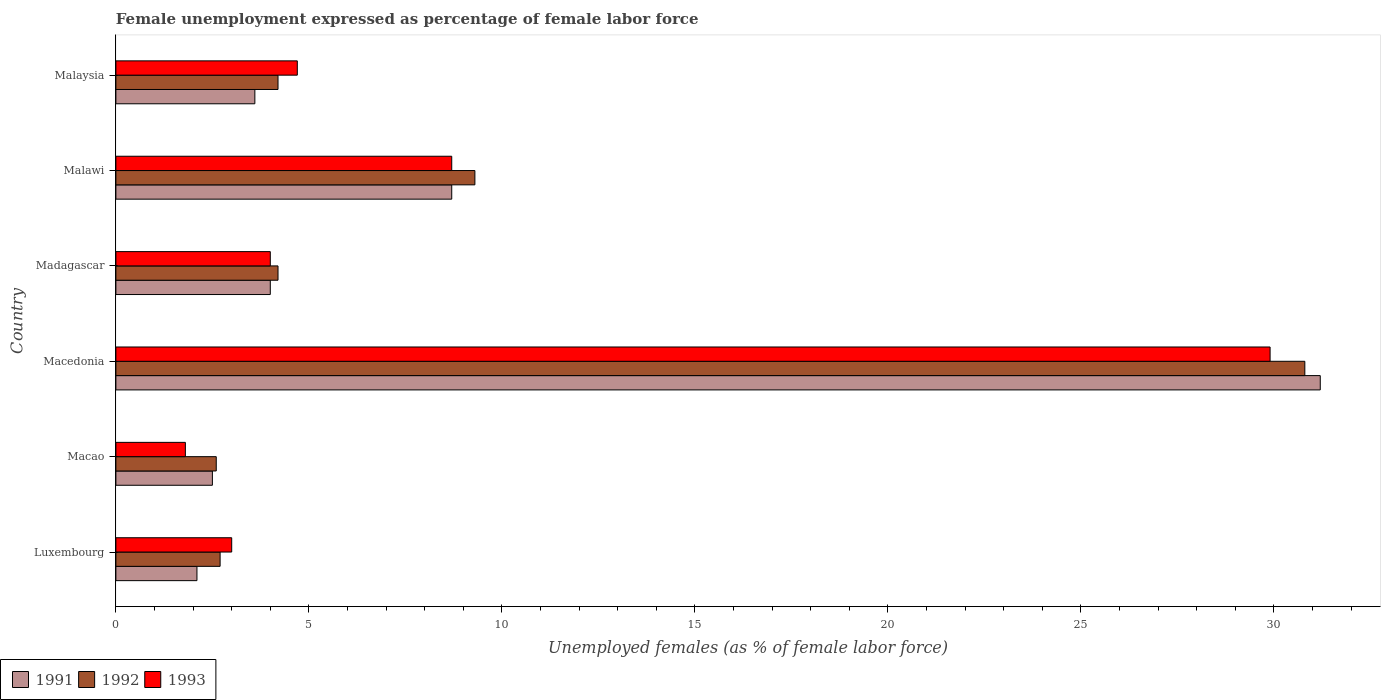How many different coloured bars are there?
Make the answer very short. 3. Are the number of bars on each tick of the Y-axis equal?
Give a very brief answer. Yes. How many bars are there on the 4th tick from the top?
Provide a succinct answer. 3. What is the label of the 4th group of bars from the top?
Ensure brevity in your answer.  Macedonia. In how many cases, is the number of bars for a given country not equal to the number of legend labels?
Ensure brevity in your answer.  0. What is the unemployment in females in in 1991 in Malawi?
Offer a very short reply. 8.7. Across all countries, what is the maximum unemployment in females in in 1992?
Make the answer very short. 30.8. Across all countries, what is the minimum unemployment in females in in 1993?
Your answer should be very brief. 1.8. In which country was the unemployment in females in in 1993 maximum?
Provide a short and direct response. Macedonia. In which country was the unemployment in females in in 1991 minimum?
Offer a terse response. Luxembourg. What is the total unemployment in females in in 1992 in the graph?
Keep it short and to the point. 53.8. What is the difference between the unemployment in females in in 1991 in Luxembourg and that in Malawi?
Your answer should be very brief. -6.6. What is the difference between the unemployment in females in in 1993 in Malaysia and the unemployment in females in in 1991 in Macedonia?
Ensure brevity in your answer.  -26.5. What is the average unemployment in females in in 1992 per country?
Make the answer very short. 8.97. What is the difference between the unemployment in females in in 1992 and unemployment in females in in 1993 in Malaysia?
Ensure brevity in your answer.  -0.5. In how many countries, is the unemployment in females in in 1992 greater than 7 %?
Make the answer very short. 2. What is the ratio of the unemployment in females in in 1993 in Luxembourg to that in Malaysia?
Your answer should be very brief. 0.64. What is the difference between the highest and the second highest unemployment in females in in 1991?
Offer a very short reply. 22.5. What is the difference between the highest and the lowest unemployment in females in in 1991?
Offer a terse response. 29.1. In how many countries, is the unemployment in females in in 1993 greater than the average unemployment in females in in 1993 taken over all countries?
Keep it short and to the point. 2. Is the sum of the unemployment in females in in 1993 in Luxembourg and Macao greater than the maximum unemployment in females in in 1991 across all countries?
Keep it short and to the point. No. How many bars are there?
Make the answer very short. 18. What is the difference between two consecutive major ticks on the X-axis?
Give a very brief answer. 5. Does the graph contain any zero values?
Give a very brief answer. No. Where does the legend appear in the graph?
Your answer should be very brief. Bottom left. How many legend labels are there?
Ensure brevity in your answer.  3. How are the legend labels stacked?
Ensure brevity in your answer.  Horizontal. What is the title of the graph?
Keep it short and to the point. Female unemployment expressed as percentage of female labor force. What is the label or title of the X-axis?
Your response must be concise. Unemployed females (as % of female labor force). What is the Unemployed females (as % of female labor force) of 1991 in Luxembourg?
Your answer should be compact. 2.1. What is the Unemployed females (as % of female labor force) of 1992 in Luxembourg?
Your response must be concise. 2.7. What is the Unemployed females (as % of female labor force) of 1991 in Macao?
Ensure brevity in your answer.  2.5. What is the Unemployed females (as % of female labor force) in 1992 in Macao?
Provide a succinct answer. 2.6. What is the Unemployed females (as % of female labor force) in 1993 in Macao?
Ensure brevity in your answer.  1.8. What is the Unemployed females (as % of female labor force) in 1991 in Macedonia?
Give a very brief answer. 31.2. What is the Unemployed females (as % of female labor force) of 1992 in Macedonia?
Your answer should be very brief. 30.8. What is the Unemployed females (as % of female labor force) of 1993 in Macedonia?
Your response must be concise. 29.9. What is the Unemployed females (as % of female labor force) of 1992 in Madagascar?
Ensure brevity in your answer.  4.2. What is the Unemployed females (as % of female labor force) of 1991 in Malawi?
Keep it short and to the point. 8.7. What is the Unemployed females (as % of female labor force) of 1992 in Malawi?
Offer a terse response. 9.3. What is the Unemployed females (as % of female labor force) in 1993 in Malawi?
Ensure brevity in your answer.  8.7. What is the Unemployed females (as % of female labor force) in 1991 in Malaysia?
Offer a very short reply. 3.6. What is the Unemployed females (as % of female labor force) of 1992 in Malaysia?
Keep it short and to the point. 4.2. What is the Unemployed females (as % of female labor force) of 1993 in Malaysia?
Your answer should be very brief. 4.7. Across all countries, what is the maximum Unemployed females (as % of female labor force) of 1991?
Provide a succinct answer. 31.2. Across all countries, what is the maximum Unemployed females (as % of female labor force) of 1992?
Your response must be concise. 30.8. Across all countries, what is the maximum Unemployed females (as % of female labor force) of 1993?
Keep it short and to the point. 29.9. Across all countries, what is the minimum Unemployed females (as % of female labor force) in 1991?
Your answer should be compact. 2.1. Across all countries, what is the minimum Unemployed females (as % of female labor force) of 1992?
Your answer should be very brief. 2.6. Across all countries, what is the minimum Unemployed females (as % of female labor force) of 1993?
Keep it short and to the point. 1.8. What is the total Unemployed females (as % of female labor force) in 1991 in the graph?
Make the answer very short. 52.1. What is the total Unemployed females (as % of female labor force) in 1992 in the graph?
Your answer should be very brief. 53.8. What is the total Unemployed females (as % of female labor force) of 1993 in the graph?
Make the answer very short. 52.1. What is the difference between the Unemployed females (as % of female labor force) in 1991 in Luxembourg and that in Macedonia?
Ensure brevity in your answer.  -29.1. What is the difference between the Unemployed females (as % of female labor force) in 1992 in Luxembourg and that in Macedonia?
Give a very brief answer. -28.1. What is the difference between the Unemployed females (as % of female labor force) in 1993 in Luxembourg and that in Macedonia?
Your response must be concise. -26.9. What is the difference between the Unemployed females (as % of female labor force) in 1991 in Luxembourg and that in Madagascar?
Ensure brevity in your answer.  -1.9. What is the difference between the Unemployed females (as % of female labor force) in 1992 in Luxembourg and that in Madagascar?
Offer a terse response. -1.5. What is the difference between the Unemployed females (as % of female labor force) in 1993 in Luxembourg and that in Madagascar?
Ensure brevity in your answer.  -1. What is the difference between the Unemployed females (as % of female labor force) of 1991 in Luxembourg and that in Malawi?
Your response must be concise. -6.6. What is the difference between the Unemployed females (as % of female labor force) in 1992 in Luxembourg and that in Malawi?
Your response must be concise. -6.6. What is the difference between the Unemployed females (as % of female labor force) in 1991 in Luxembourg and that in Malaysia?
Your response must be concise. -1.5. What is the difference between the Unemployed females (as % of female labor force) of 1992 in Luxembourg and that in Malaysia?
Provide a short and direct response. -1.5. What is the difference between the Unemployed females (as % of female labor force) of 1991 in Macao and that in Macedonia?
Give a very brief answer. -28.7. What is the difference between the Unemployed females (as % of female labor force) in 1992 in Macao and that in Macedonia?
Your response must be concise. -28.2. What is the difference between the Unemployed females (as % of female labor force) of 1993 in Macao and that in Macedonia?
Your response must be concise. -28.1. What is the difference between the Unemployed females (as % of female labor force) in 1991 in Macao and that in Madagascar?
Your response must be concise. -1.5. What is the difference between the Unemployed females (as % of female labor force) of 1993 in Macao and that in Madagascar?
Your answer should be compact. -2.2. What is the difference between the Unemployed females (as % of female labor force) in 1992 in Macao and that in Malawi?
Provide a succinct answer. -6.7. What is the difference between the Unemployed females (as % of female labor force) of 1993 in Macao and that in Malawi?
Your response must be concise. -6.9. What is the difference between the Unemployed females (as % of female labor force) of 1991 in Macao and that in Malaysia?
Your response must be concise. -1.1. What is the difference between the Unemployed females (as % of female labor force) in 1992 in Macao and that in Malaysia?
Offer a very short reply. -1.6. What is the difference between the Unemployed females (as % of female labor force) of 1993 in Macao and that in Malaysia?
Offer a terse response. -2.9. What is the difference between the Unemployed females (as % of female labor force) of 1991 in Macedonia and that in Madagascar?
Offer a terse response. 27.2. What is the difference between the Unemployed females (as % of female labor force) in 1992 in Macedonia and that in Madagascar?
Offer a very short reply. 26.6. What is the difference between the Unemployed females (as % of female labor force) of 1993 in Macedonia and that in Madagascar?
Keep it short and to the point. 25.9. What is the difference between the Unemployed females (as % of female labor force) of 1991 in Macedonia and that in Malawi?
Provide a succinct answer. 22.5. What is the difference between the Unemployed females (as % of female labor force) in 1992 in Macedonia and that in Malawi?
Give a very brief answer. 21.5. What is the difference between the Unemployed females (as % of female labor force) of 1993 in Macedonia and that in Malawi?
Offer a very short reply. 21.2. What is the difference between the Unemployed females (as % of female labor force) of 1991 in Macedonia and that in Malaysia?
Offer a very short reply. 27.6. What is the difference between the Unemployed females (as % of female labor force) in 1992 in Macedonia and that in Malaysia?
Your answer should be very brief. 26.6. What is the difference between the Unemployed females (as % of female labor force) of 1993 in Macedonia and that in Malaysia?
Provide a short and direct response. 25.2. What is the difference between the Unemployed females (as % of female labor force) of 1991 in Madagascar and that in Malawi?
Provide a succinct answer. -4.7. What is the difference between the Unemployed females (as % of female labor force) of 1993 in Madagascar and that in Malawi?
Offer a terse response. -4.7. What is the difference between the Unemployed females (as % of female labor force) in 1993 in Madagascar and that in Malaysia?
Your response must be concise. -0.7. What is the difference between the Unemployed females (as % of female labor force) of 1991 in Malawi and that in Malaysia?
Provide a succinct answer. 5.1. What is the difference between the Unemployed females (as % of female labor force) of 1992 in Malawi and that in Malaysia?
Give a very brief answer. 5.1. What is the difference between the Unemployed females (as % of female labor force) of 1993 in Malawi and that in Malaysia?
Ensure brevity in your answer.  4. What is the difference between the Unemployed females (as % of female labor force) of 1991 in Luxembourg and the Unemployed females (as % of female labor force) of 1992 in Macao?
Your response must be concise. -0.5. What is the difference between the Unemployed females (as % of female labor force) in 1992 in Luxembourg and the Unemployed females (as % of female labor force) in 1993 in Macao?
Ensure brevity in your answer.  0.9. What is the difference between the Unemployed females (as % of female labor force) in 1991 in Luxembourg and the Unemployed females (as % of female labor force) in 1992 in Macedonia?
Your answer should be very brief. -28.7. What is the difference between the Unemployed females (as % of female labor force) in 1991 in Luxembourg and the Unemployed females (as % of female labor force) in 1993 in Macedonia?
Offer a very short reply. -27.8. What is the difference between the Unemployed females (as % of female labor force) in 1992 in Luxembourg and the Unemployed females (as % of female labor force) in 1993 in Macedonia?
Your answer should be very brief. -27.2. What is the difference between the Unemployed females (as % of female labor force) of 1991 in Luxembourg and the Unemployed females (as % of female labor force) of 1992 in Madagascar?
Offer a terse response. -2.1. What is the difference between the Unemployed females (as % of female labor force) of 1991 in Luxembourg and the Unemployed females (as % of female labor force) of 1992 in Malawi?
Your answer should be very brief. -7.2. What is the difference between the Unemployed females (as % of female labor force) in 1992 in Luxembourg and the Unemployed females (as % of female labor force) in 1993 in Malawi?
Offer a very short reply. -6. What is the difference between the Unemployed females (as % of female labor force) in 1991 in Macao and the Unemployed females (as % of female labor force) in 1992 in Macedonia?
Ensure brevity in your answer.  -28.3. What is the difference between the Unemployed females (as % of female labor force) of 1991 in Macao and the Unemployed females (as % of female labor force) of 1993 in Macedonia?
Your answer should be very brief. -27.4. What is the difference between the Unemployed females (as % of female labor force) of 1992 in Macao and the Unemployed females (as % of female labor force) of 1993 in Macedonia?
Your answer should be very brief. -27.3. What is the difference between the Unemployed females (as % of female labor force) of 1991 in Macao and the Unemployed females (as % of female labor force) of 1992 in Madagascar?
Give a very brief answer. -1.7. What is the difference between the Unemployed females (as % of female labor force) of 1991 in Macao and the Unemployed females (as % of female labor force) of 1993 in Madagascar?
Your answer should be compact. -1.5. What is the difference between the Unemployed females (as % of female labor force) of 1991 in Macao and the Unemployed females (as % of female labor force) of 1992 in Malawi?
Keep it short and to the point. -6.8. What is the difference between the Unemployed females (as % of female labor force) of 1991 in Macao and the Unemployed females (as % of female labor force) of 1993 in Malawi?
Make the answer very short. -6.2. What is the difference between the Unemployed females (as % of female labor force) of 1992 in Macao and the Unemployed females (as % of female labor force) of 1993 in Malawi?
Ensure brevity in your answer.  -6.1. What is the difference between the Unemployed females (as % of female labor force) of 1991 in Macedonia and the Unemployed females (as % of female labor force) of 1993 in Madagascar?
Provide a short and direct response. 27.2. What is the difference between the Unemployed females (as % of female labor force) of 1992 in Macedonia and the Unemployed females (as % of female labor force) of 1993 in Madagascar?
Give a very brief answer. 26.8. What is the difference between the Unemployed females (as % of female labor force) in 1991 in Macedonia and the Unemployed females (as % of female labor force) in 1992 in Malawi?
Provide a short and direct response. 21.9. What is the difference between the Unemployed females (as % of female labor force) of 1992 in Macedonia and the Unemployed females (as % of female labor force) of 1993 in Malawi?
Make the answer very short. 22.1. What is the difference between the Unemployed females (as % of female labor force) of 1991 in Macedonia and the Unemployed females (as % of female labor force) of 1993 in Malaysia?
Ensure brevity in your answer.  26.5. What is the difference between the Unemployed females (as % of female labor force) of 1992 in Macedonia and the Unemployed females (as % of female labor force) of 1993 in Malaysia?
Ensure brevity in your answer.  26.1. What is the difference between the Unemployed females (as % of female labor force) in 1991 in Madagascar and the Unemployed females (as % of female labor force) in 1992 in Malawi?
Your response must be concise. -5.3. What is the difference between the Unemployed females (as % of female labor force) of 1991 in Madagascar and the Unemployed females (as % of female labor force) of 1993 in Malawi?
Offer a very short reply. -4.7. What is the difference between the Unemployed females (as % of female labor force) of 1992 in Madagascar and the Unemployed females (as % of female labor force) of 1993 in Malawi?
Provide a short and direct response. -4.5. What is the difference between the Unemployed females (as % of female labor force) of 1991 in Madagascar and the Unemployed females (as % of female labor force) of 1992 in Malaysia?
Keep it short and to the point. -0.2. What is the difference between the Unemployed females (as % of female labor force) in 1991 in Malawi and the Unemployed females (as % of female labor force) in 1992 in Malaysia?
Keep it short and to the point. 4.5. What is the difference between the Unemployed females (as % of female labor force) of 1991 in Malawi and the Unemployed females (as % of female labor force) of 1993 in Malaysia?
Offer a very short reply. 4. What is the average Unemployed females (as % of female labor force) of 1991 per country?
Make the answer very short. 8.68. What is the average Unemployed females (as % of female labor force) in 1992 per country?
Ensure brevity in your answer.  8.97. What is the average Unemployed females (as % of female labor force) in 1993 per country?
Your answer should be compact. 8.68. What is the difference between the Unemployed females (as % of female labor force) of 1991 and Unemployed females (as % of female labor force) of 1992 in Luxembourg?
Provide a short and direct response. -0.6. What is the difference between the Unemployed females (as % of female labor force) of 1991 and Unemployed females (as % of female labor force) of 1992 in Macao?
Provide a succinct answer. -0.1. What is the difference between the Unemployed females (as % of female labor force) of 1992 and Unemployed females (as % of female labor force) of 1993 in Macao?
Provide a short and direct response. 0.8. What is the difference between the Unemployed females (as % of female labor force) in 1992 and Unemployed females (as % of female labor force) in 1993 in Macedonia?
Your response must be concise. 0.9. What is the difference between the Unemployed females (as % of female labor force) of 1991 and Unemployed females (as % of female labor force) of 1992 in Madagascar?
Keep it short and to the point. -0.2. What is the difference between the Unemployed females (as % of female labor force) of 1991 and Unemployed females (as % of female labor force) of 1993 in Madagascar?
Ensure brevity in your answer.  0. What is the difference between the Unemployed females (as % of female labor force) in 1991 and Unemployed females (as % of female labor force) in 1992 in Malawi?
Give a very brief answer. -0.6. What is the difference between the Unemployed females (as % of female labor force) in 1991 and Unemployed females (as % of female labor force) in 1993 in Malawi?
Ensure brevity in your answer.  0. What is the difference between the Unemployed females (as % of female labor force) in 1992 and Unemployed females (as % of female labor force) in 1993 in Malawi?
Your answer should be very brief. 0.6. What is the difference between the Unemployed females (as % of female labor force) in 1991 and Unemployed females (as % of female labor force) in 1992 in Malaysia?
Your answer should be very brief. -0.6. What is the difference between the Unemployed females (as % of female labor force) of 1992 and Unemployed females (as % of female labor force) of 1993 in Malaysia?
Offer a very short reply. -0.5. What is the ratio of the Unemployed females (as % of female labor force) in 1991 in Luxembourg to that in Macao?
Give a very brief answer. 0.84. What is the ratio of the Unemployed females (as % of female labor force) of 1992 in Luxembourg to that in Macao?
Keep it short and to the point. 1.04. What is the ratio of the Unemployed females (as % of female labor force) of 1993 in Luxembourg to that in Macao?
Provide a short and direct response. 1.67. What is the ratio of the Unemployed females (as % of female labor force) of 1991 in Luxembourg to that in Macedonia?
Ensure brevity in your answer.  0.07. What is the ratio of the Unemployed females (as % of female labor force) of 1992 in Luxembourg to that in Macedonia?
Provide a short and direct response. 0.09. What is the ratio of the Unemployed females (as % of female labor force) in 1993 in Luxembourg to that in Macedonia?
Ensure brevity in your answer.  0.1. What is the ratio of the Unemployed females (as % of female labor force) of 1991 in Luxembourg to that in Madagascar?
Give a very brief answer. 0.53. What is the ratio of the Unemployed females (as % of female labor force) of 1992 in Luxembourg to that in Madagascar?
Keep it short and to the point. 0.64. What is the ratio of the Unemployed females (as % of female labor force) of 1993 in Luxembourg to that in Madagascar?
Offer a terse response. 0.75. What is the ratio of the Unemployed females (as % of female labor force) in 1991 in Luxembourg to that in Malawi?
Your response must be concise. 0.24. What is the ratio of the Unemployed females (as % of female labor force) of 1992 in Luxembourg to that in Malawi?
Keep it short and to the point. 0.29. What is the ratio of the Unemployed females (as % of female labor force) of 1993 in Luxembourg to that in Malawi?
Offer a very short reply. 0.34. What is the ratio of the Unemployed females (as % of female labor force) in 1991 in Luxembourg to that in Malaysia?
Your answer should be very brief. 0.58. What is the ratio of the Unemployed females (as % of female labor force) of 1992 in Luxembourg to that in Malaysia?
Provide a succinct answer. 0.64. What is the ratio of the Unemployed females (as % of female labor force) of 1993 in Luxembourg to that in Malaysia?
Provide a short and direct response. 0.64. What is the ratio of the Unemployed females (as % of female labor force) in 1991 in Macao to that in Macedonia?
Ensure brevity in your answer.  0.08. What is the ratio of the Unemployed females (as % of female labor force) of 1992 in Macao to that in Macedonia?
Make the answer very short. 0.08. What is the ratio of the Unemployed females (as % of female labor force) of 1993 in Macao to that in Macedonia?
Offer a terse response. 0.06. What is the ratio of the Unemployed females (as % of female labor force) of 1992 in Macao to that in Madagascar?
Provide a succinct answer. 0.62. What is the ratio of the Unemployed females (as % of female labor force) in 1993 in Macao to that in Madagascar?
Offer a very short reply. 0.45. What is the ratio of the Unemployed females (as % of female labor force) in 1991 in Macao to that in Malawi?
Ensure brevity in your answer.  0.29. What is the ratio of the Unemployed females (as % of female labor force) of 1992 in Macao to that in Malawi?
Give a very brief answer. 0.28. What is the ratio of the Unemployed females (as % of female labor force) of 1993 in Macao to that in Malawi?
Keep it short and to the point. 0.21. What is the ratio of the Unemployed females (as % of female labor force) of 1991 in Macao to that in Malaysia?
Offer a terse response. 0.69. What is the ratio of the Unemployed females (as % of female labor force) in 1992 in Macao to that in Malaysia?
Your answer should be very brief. 0.62. What is the ratio of the Unemployed females (as % of female labor force) in 1993 in Macao to that in Malaysia?
Offer a terse response. 0.38. What is the ratio of the Unemployed females (as % of female labor force) in 1991 in Macedonia to that in Madagascar?
Provide a short and direct response. 7.8. What is the ratio of the Unemployed females (as % of female labor force) of 1992 in Macedonia to that in Madagascar?
Provide a short and direct response. 7.33. What is the ratio of the Unemployed females (as % of female labor force) of 1993 in Macedonia to that in Madagascar?
Ensure brevity in your answer.  7.47. What is the ratio of the Unemployed females (as % of female labor force) in 1991 in Macedonia to that in Malawi?
Keep it short and to the point. 3.59. What is the ratio of the Unemployed females (as % of female labor force) in 1992 in Macedonia to that in Malawi?
Your answer should be compact. 3.31. What is the ratio of the Unemployed females (as % of female labor force) in 1993 in Macedonia to that in Malawi?
Offer a terse response. 3.44. What is the ratio of the Unemployed females (as % of female labor force) of 1991 in Macedonia to that in Malaysia?
Give a very brief answer. 8.67. What is the ratio of the Unemployed females (as % of female labor force) of 1992 in Macedonia to that in Malaysia?
Keep it short and to the point. 7.33. What is the ratio of the Unemployed females (as % of female labor force) in 1993 in Macedonia to that in Malaysia?
Keep it short and to the point. 6.36. What is the ratio of the Unemployed females (as % of female labor force) in 1991 in Madagascar to that in Malawi?
Ensure brevity in your answer.  0.46. What is the ratio of the Unemployed females (as % of female labor force) in 1992 in Madagascar to that in Malawi?
Provide a short and direct response. 0.45. What is the ratio of the Unemployed females (as % of female labor force) in 1993 in Madagascar to that in Malawi?
Ensure brevity in your answer.  0.46. What is the ratio of the Unemployed females (as % of female labor force) of 1992 in Madagascar to that in Malaysia?
Your response must be concise. 1. What is the ratio of the Unemployed females (as % of female labor force) in 1993 in Madagascar to that in Malaysia?
Offer a very short reply. 0.85. What is the ratio of the Unemployed females (as % of female labor force) of 1991 in Malawi to that in Malaysia?
Your response must be concise. 2.42. What is the ratio of the Unemployed females (as % of female labor force) in 1992 in Malawi to that in Malaysia?
Provide a succinct answer. 2.21. What is the ratio of the Unemployed females (as % of female labor force) of 1993 in Malawi to that in Malaysia?
Your response must be concise. 1.85. What is the difference between the highest and the second highest Unemployed females (as % of female labor force) of 1991?
Give a very brief answer. 22.5. What is the difference between the highest and the second highest Unemployed females (as % of female labor force) of 1992?
Your answer should be very brief. 21.5. What is the difference between the highest and the second highest Unemployed females (as % of female labor force) of 1993?
Your answer should be very brief. 21.2. What is the difference between the highest and the lowest Unemployed females (as % of female labor force) in 1991?
Your answer should be very brief. 29.1. What is the difference between the highest and the lowest Unemployed females (as % of female labor force) of 1992?
Make the answer very short. 28.2. What is the difference between the highest and the lowest Unemployed females (as % of female labor force) in 1993?
Your response must be concise. 28.1. 